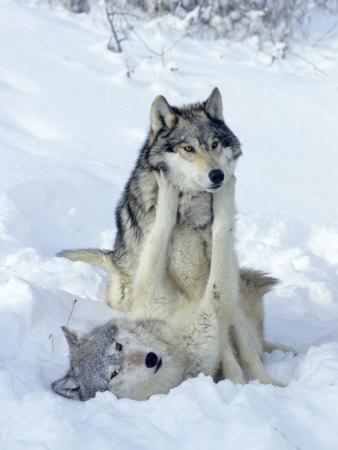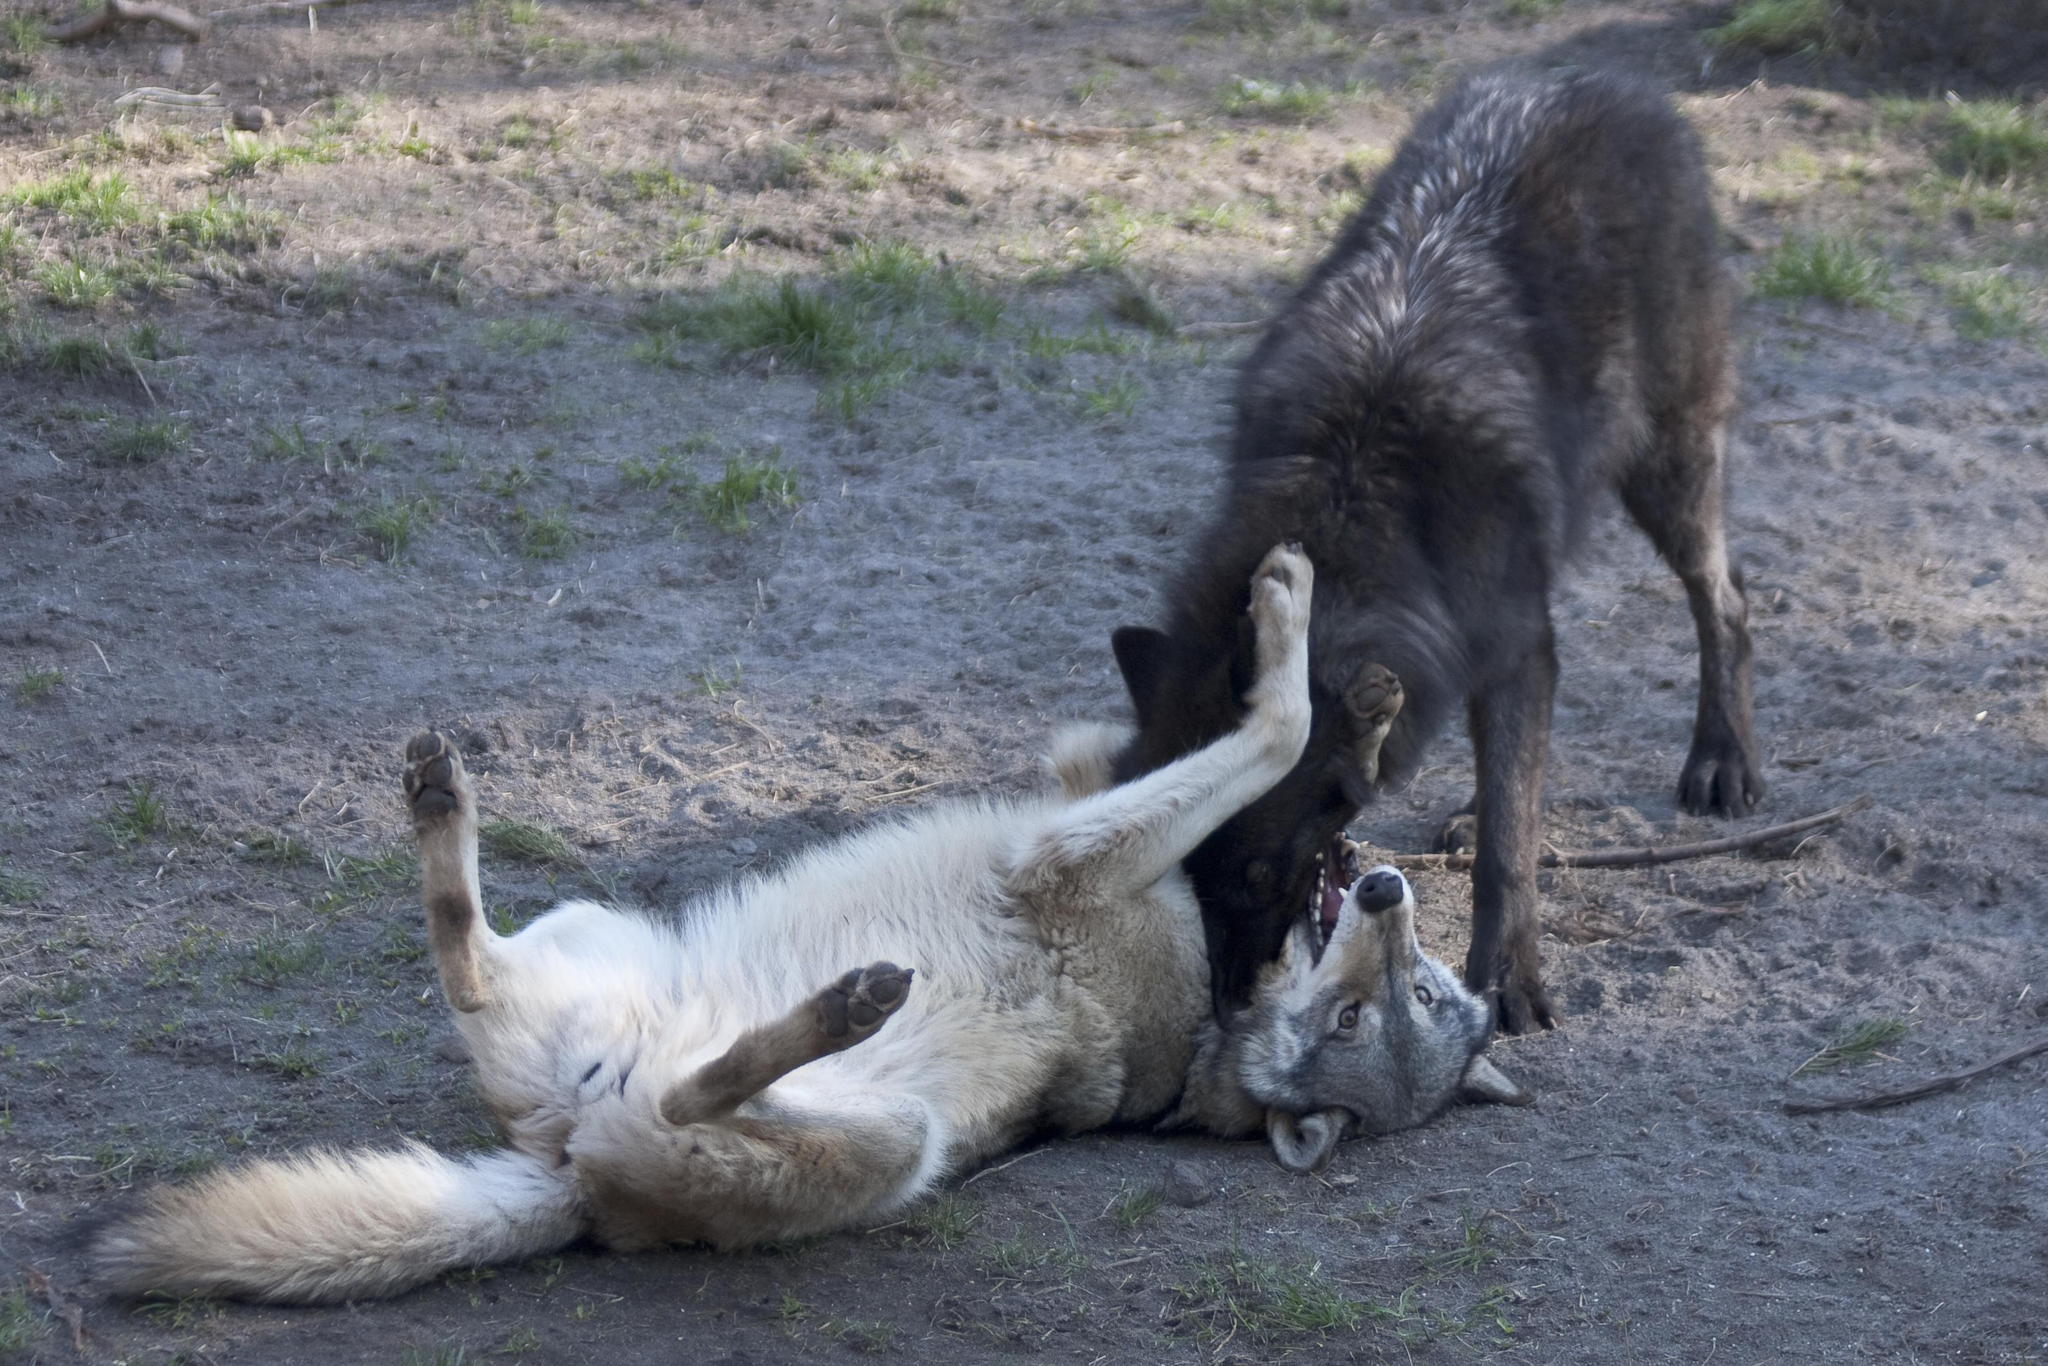The first image is the image on the left, the second image is the image on the right. Given the left and right images, does the statement "The right image shows one wolf standing over another wolf that is lying on its back with its rear to the camera and multiple paws in the air." hold true? Answer yes or no. Yes. The first image is the image on the left, the second image is the image on the right. Assess this claim about the two images: "At least one of the dogs is lying on the ground.". Correct or not? Answer yes or no. Yes. 